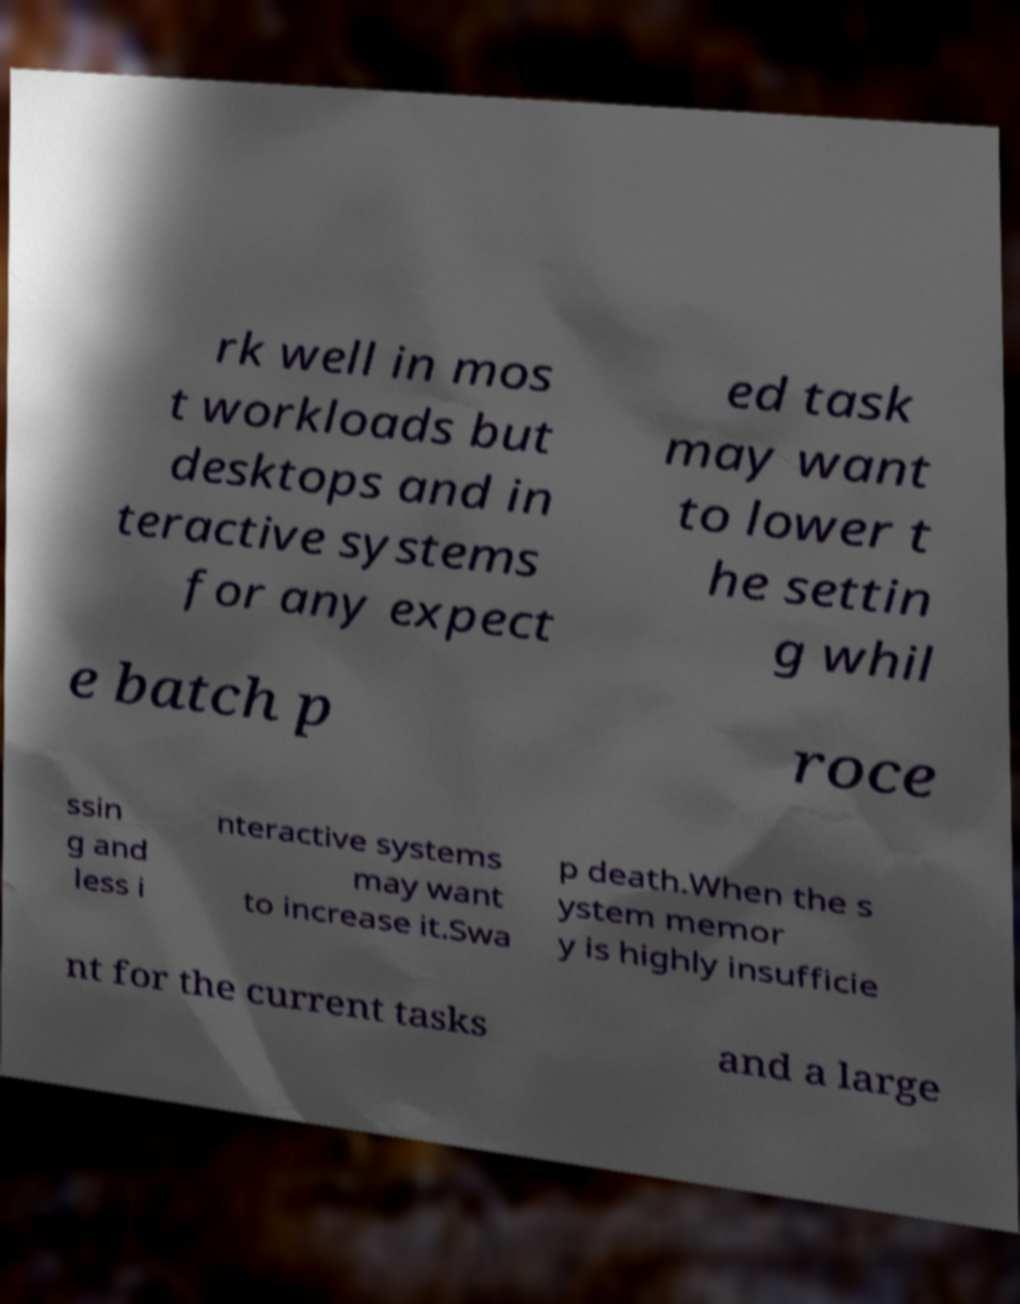What messages or text are displayed in this image? I need them in a readable, typed format. rk well in mos t workloads but desktops and in teractive systems for any expect ed task may want to lower t he settin g whil e batch p roce ssin g and less i nteractive systems may want to increase it.Swa p death.When the s ystem memor y is highly insufficie nt for the current tasks and a large 